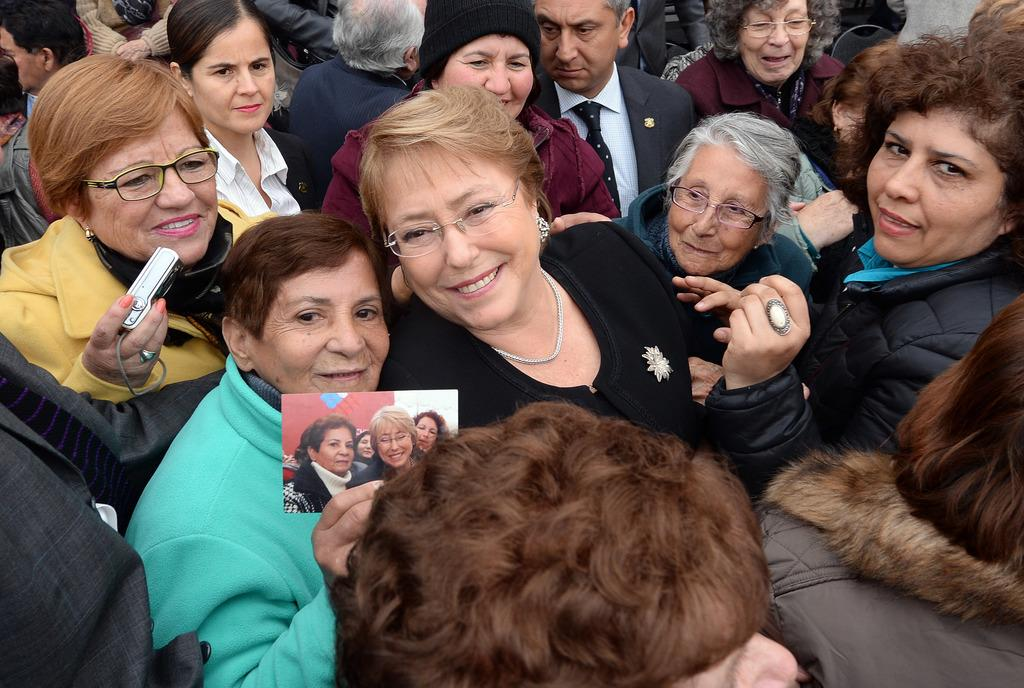Where was the image taken? The image was taken outdoors. How many people are in the image? There are many people in the image. What is the facial expression of the people in the image? The people have smiling faces. What type of linen can be seen draped over the furniture in the image? There is no linen or furniture present in the image; it features many people with smiling faces outdoors. 